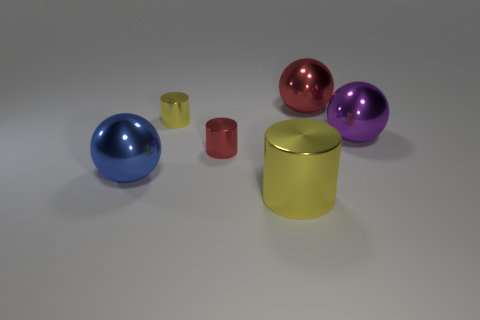Subtract all tiny metal cylinders. How many cylinders are left? 1 Subtract all purple spheres. How many yellow cylinders are left? 2 Add 1 large cyan cylinders. How many objects exist? 7 Subtract all yellow cylinders. How many cylinders are left? 1 Subtract 1 spheres. How many spheres are left? 2 Subtract all gray cylinders. Subtract all red blocks. How many cylinders are left? 3 Subtract all tiny objects. Subtract all big purple objects. How many objects are left? 3 Add 5 small yellow metallic cylinders. How many small yellow metallic cylinders are left? 6 Add 2 big metallic things. How many big metallic things exist? 6 Subtract 0 brown balls. How many objects are left? 6 